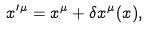<formula> <loc_0><loc_0><loc_500><loc_500>x ^ { \prime \mu } = x ^ { \mu } + \delta x ^ { \mu } ( x ) ,</formula> 